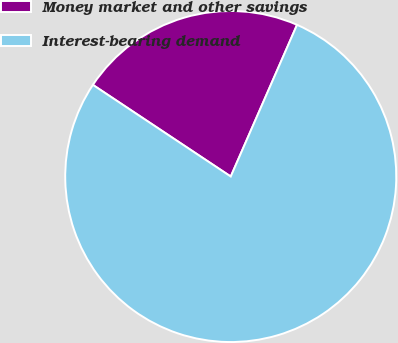Convert chart to OTSL. <chart><loc_0><loc_0><loc_500><loc_500><pie_chart><fcel>Money market and other savings<fcel>Interest-bearing demand<nl><fcel>22.22%<fcel>77.78%<nl></chart> 